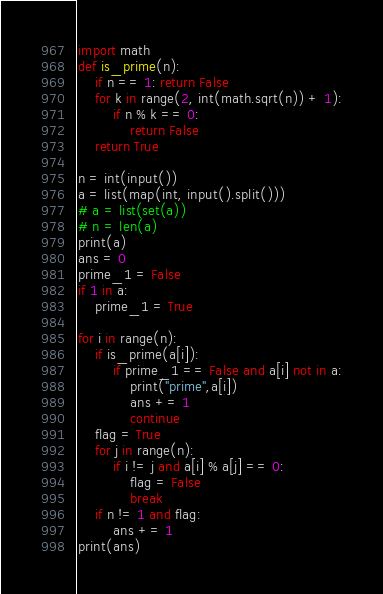Convert code to text. <code><loc_0><loc_0><loc_500><loc_500><_Python_>import math
def is_prime(n):
    if n == 1: return False
    for k in range(2, int(math.sqrt(n)) + 1):
        if n % k == 0:
            return False
    return True

n = int(input())
a = list(map(int, input().split()))
# a = list(set(a))
# n = len(a)
print(a)
ans = 0
prime_1 = False
if 1 in a:
    prime_1 = True

for i in range(n):
    if is_prime(a[i]):
        if prime_1 == False and a[i] not in a:
            print("prime",a[i])
            ans += 1
            continue
    flag = True
    for j in range(n):
        if i != j and a[i] % a[j] == 0:
            flag = False
            break
    if n != 1 and flag:
        ans += 1
print(ans)
</code> 